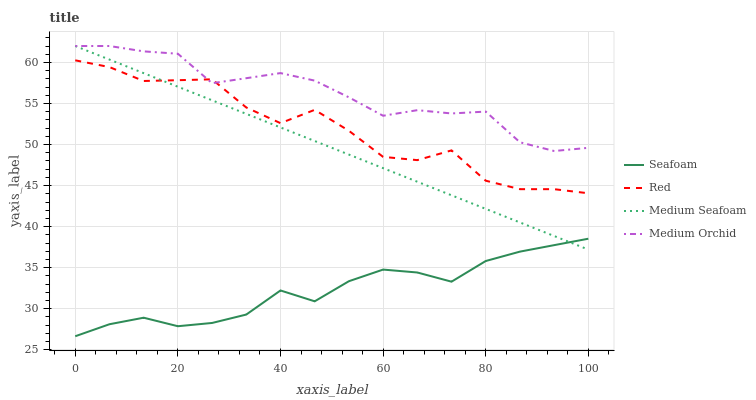Does Seafoam have the minimum area under the curve?
Answer yes or no. Yes. Does Medium Orchid have the maximum area under the curve?
Answer yes or no. Yes. Does Red have the minimum area under the curve?
Answer yes or no. No. Does Red have the maximum area under the curve?
Answer yes or no. No. Is Medium Seafoam the smoothest?
Answer yes or no. Yes. Is Red the roughest?
Answer yes or no. Yes. Is Seafoam the smoothest?
Answer yes or no. No. Is Seafoam the roughest?
Answer yes or no. No. Does Seafoam have the lowest value?
Answer yes or no. Yes. Does Red have the lowest value?
Answer yes or no. No. Does Medium Seafoam have the highest value?
Answer yes or no. Yes. Does Red have the highest value?
Answer yes or no. No. Is Seafoam less than Red?
Answer yes or no. Yes. Is Medium Orchid greater than Seafoam?
Answer yes or no. Yes. Does Medium Orchid intersect Medium Seafoam?
Answer yes or no. Yes. Is Medium Orchid less than Medium Seafoam?
Answer yes or no. No. Is Medium Orchid greater than Medium Seafoam?
Answer yes or no. No. Does Seafoam intersect Red?
Answer yes or no. No. 